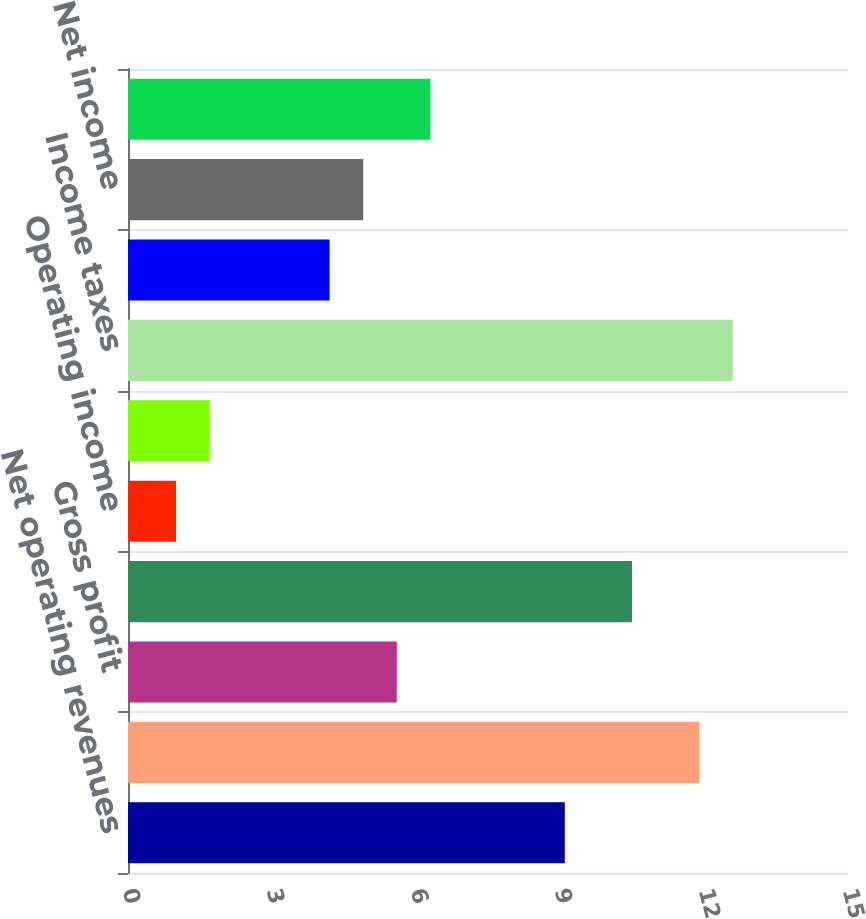<chart> <loc_0><loc_0><loc_500><loc_500><bar_chart><fcel>Net operating revenues<fcel>Cost of goods sold<fcel>Gross profit<fcel>Selling general and<fcel>Operating income<fcel>Income before income taxes and<fcel>Income taxes<fcel>Net income before changes in<fcel>Net income<fcel>Income before changes in<nl><fcel>9.1<fcel>11.9<fcel>5.6<fcel>10.5<fcel>1<fcel>1.7<fcel>12.6<fcel>4.2<fcel>4.9<fcel>6.3<nl></chart> 